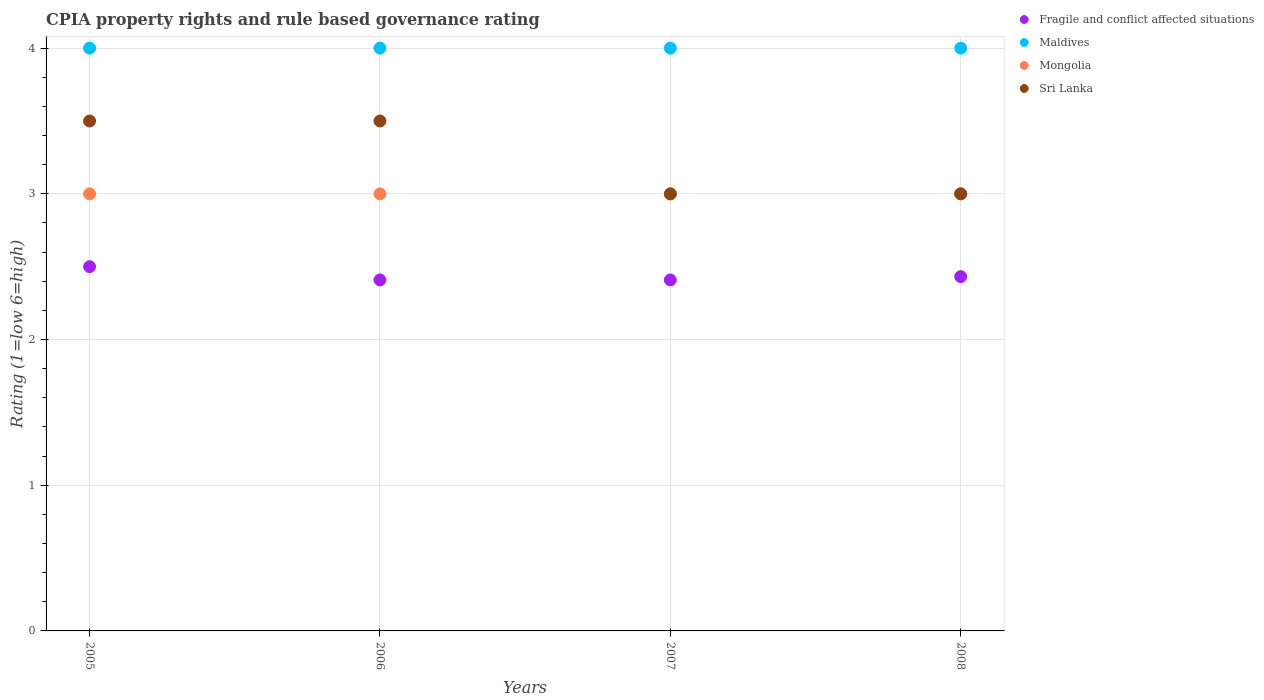How many different coloured dotlines are there?
Your answer should be very brief. 4. What is the CPIA rating in Mongolia in 2007?
Provide a short and direct response. 3. Across all years, what is the minimum CPIA rating in Mongolia?
Make the answer very short. 3. What is the total CPIA rating in Fragile and conflict affected situations in the graph?
Offer a very short reply. 9.75. What is the difference between the CPIA rating in Fragile and conflict affected situations in 2006 and the CPIA rating in Maldives in 2008?
Your response must be concise. -1.59. Is the CPIA rating in Sri Lanka in 2007 less than that in 2008?
Keep it short and to the point. No. What is the difference between the highest and the second highest CPIA rating in Mongolia?
Make the answer very short. 0. In how many years, is the CPIA rating in Mongolia greater than the average CPIA rating in Mongolia taken over all years?
Give a very brief answer. 0. Does the CPIA rating in Maldives monotonically increase over the years?
Your response must be concise. No. Is the CPIA rating in Fragile and conflict affected situations strictly greater than the CPIA rating in Mongolia over the years?
Offer a very short reply. No. Is the CPIA rating in Maldives strictly less than the CPIA rating in Mongolia over the years?
Your answer should be very brief. No. Are the values on the major ticks of Y-axis written in scientific E-notation?
Give a very brief answer. No. Does the graph contain any zero values?
Provide a short and direct response. No. Does the graph contain grids?
Your answer should be compact. Yes. What is the title of the graph?
Your answer should be very brief. CPIA property rights and rule based governance rating. Does "Tuvalu" appear as one of the legend labels in the graph?
Your answer should be compact. No. What is the label or title of the X-axis?
Your response must be concise. Years. What is the label or title of the Y-axis?
Ensure brevity in your answer.  Rating (1=low 6=high). What is the Rating (1=low 6=high) of Mongolia in 2005?
Ensure brevity in your answer.  3. What is the Rating (1=low 6=high) of Sri Lanka in 2005?
Provide a short and direct response. 3.5. What is the Rating (1=low 6=high) in Fragile and conflict affected situations in 2006?
Give a very brief answer. 2.41. What is the Rating (1=low 6=high) in Maldives in 2006?
Make the answer very short. 4. What is the Rating (1=low 6=high) of Mongolia in 2006?
Your response must be concise. 3. What is the Rating (1=low 6=high) in Fragile and conflict affected situations in 2007?
Your answer should be compact. 2.41. What is the Rating (1=low 6=high) of Fragile and conflict affected situations in 2008?
Provide a short and direct response. 2.43. What is the Rating (1=low 6=high) of Mongolia in 2008?
Make the answer very short. 3. Across all years, what is the maximum Rating (1=low 6=high) in Fragile and conflict affected situations?
Offer a terse response. 2.5. Across all years, what is the maximum Rating (1=low 6=high) of Maldives?
Offer a terse response. 4. Across all years, what is the minimum Rating (1=low 6=high) in Fragile and conflict affected situations?
Your answer should be very brief. 2.41. Across all years, what is the minimum Rating (1=low 6=high) in Maldives?
Offer a very short reply. 4. Across all years, what is the minimum Rating (1=low 6=high) in Mongolia?
Give a very brief answer. 3. Across all years, what is the minimum Rating (1=low 6=high) in Sri Lanka?
Make the answer very short. 3. What is the total Rating (1=low 6=high) of Fragile and conflict affected situations in the graph?
Make the answer very short. 9.75. What is the total Rating (1=low 6=high) in Mongolia in the graph?
Ensure brevity in your answer.  12. What is the total Rating (1=low 6=high) of Sri Lanka in the graph?
Give a very brief answer. 13. What is the difference between the Rating (1=low 6=high) in Fragile and conflict affected situations in 2005 and that in 2006?
Offer a terse response. 0.09. What is the difference between the Rating (1=low 6=high) in Maldives in 2005 and that in 2006?
Provide a short and direct response. 0. What is the difference between the Rating (1=low 6=high) in Mongolia in 2005 and that in 2006?
Your response must be concise. 0. What is the difference between the Rating (1=low 6=high) in Fragile and conflict affected situations in 2005 and that in 2007?
Make the answer very short. 0.09. What is the difference between the Rating (1=low 6=high) of Mongolia in 2005 and that in 2007?
Ensure brevity in your answer.  0. What is the difference between the Rating (1=low 6=high) of Fragile and conflict affected situations in 2005 and that in 2008?
Provide a succinct answer. 0.07. What is the difference between the Rating (1=low 6=high) in Mongolia in 2005 and that in 2008?
Provide a succinct answer. 0. What is the difference between the Rating (1=low 6=high) of Sri Lanka in 2005 and that in 2008?
Give a very brief answer. 0.5. What is the difference between the Rating (1=low 6=high) in Mongolia in 2006 and that in 2007?
Give a very brief answer. 0. What is the difference between the Rating (1=low 6=high) in Sri Lanka in 2006 and that in 2007?
Offer a terse response. 0.5. What is the difference between the Rating (1=low 6=high) in Fragile and conflict affected situations in 2006 and that in 2008?
Make the answer very short. -0.02. What is the difference between the Rating (1=low 6=high) of Maldives in 2006 and that in 2008?
Make the answer very short. 0. What is the difference between the Rating (1=low 6=high) in Sri Lanka in 2006 and that in 2008?
Your answer should be very brief. 0.5. What is the difference between the Rating (1=low 6=high) of Fragile and conflict affected situations in 2007 and that in 2008?
Make the answer very short. -0.02. What is the difference between the Rating (1=low 6=high) in Maldives in 2007 and that in 2008?
Provide a short and direct response. 0. What is the difference between the Rating (1=low 6=high) of Mongolia in 2007 and that in 2008?
Ensure brevity in your answer.  0. What is the difference between the Rating (1=low 6=high) of Sri Lanka in 2007 and that in 2008?
Your answer should be very brief. 0. What is the difference between the Rating (1=low 6=high) in Fragile and conflict affected situations in 2005 and the Rating (1=low 6=high) in Maldives in 2006?
Offer a terse response. -1.5. What is the difference between the Rating (1=low 6=high) of Maldives in 2005 and the Rating (1=low 6=high) of Mongolia in 2006?
Offer a terse response. 1. What is the difference between the Rating (1=low 6=high) in Fragile and conflict affected situations in 2005 and the Rating (1=low 6=high) in Mongolia in 2007?
Your response must be concise. -0.5. What is the difference between the Rating (1=low 6=high) in Maldives in 2005 and the Rating (1=low 6=high) in Mongolia in 2007?
Your response must be concise. 1. What is the difference between the Rating (1=low 6=high) of Maldives in 2005 and the Rating (1=low 6=high) of Sri Lanka in 2007?
Your answer should be compact. 1. What is the difference between the Rating (1=low 6=high) of Fragile and conflict affected situations in 2005 and the Rating (1=low 6=high) of Sri Lanka in 2008?
Your answer should be compact. -0.5. What is the difference between the Rating (1=low 6=high) in Maldives in 2005 and the Rating (1=low 6=high) in Sri Lanka in 2008?
Provide a short and direct response. 1. What is the difference between the Rating (1=low 6=high) of Mongolia in 2005 and the Rating (1=low 6=high) of Sri Lanka in 2008?
Your answer should be very brief. 0. What is the difference between the Rating (1=low 6=high) of Fragile and conflict affected situations in 2006 and the Rating (1=low 6=high) of Maldives in 2007?
Ensure brevity in your answer.  -1.59. What is the difference between the Rating (1=low 6=high) of Fragile and conflict affected situations in 2006 and the Rating (1=low 6=high) of Mongolia in 2007?
Provide a succinct answer. -0.59. What is the difference between the Rating (1=low 6=high) of Fragile and conflict affected situations in 2006 and the Rating (1=low 6=high) of Sri Lanka in 2007?
Provide a short and direct response. -0.59. What is the difference between the Rating (1=low 6=high) in Maldives in 2006 and the Rating (1=low 6=high) in Mongolia in 2007?
Your answer should be compact. 1. What is the difference between the Rating (1=low 6=high) of Mongolia in 2006 and the Rating (1=low 6=high) of Sri Lanka in 2007?
Make the answer very short. 0. What is the difference between the Rating (1=low 6=high) in Fragile and conflict affected situations in 2006 and the Rating (1=low 6=high) in Maldives in 2008?
Provide a succinct answer. -1.59. What is the difference between the Rating (1=low 6=high) of Fragile and conflict affected situations in 2006 and the Rating (1=low 6=high) of Mongolia in 2008?
Ensure brevity in your answer.  -0.59. What is the difference between the Rating (1=low 6=high) in Fragile and conflict affected situations in 2006 and the Rating (1=low 6=high) in Sri Lanka in 2008?
Give a very brief answer. -0.59. What is the difference between the Rating (1=low 6=high) of Mongolia in 2006 and the Rating (1=low 6=high) of Sri Lanka in 2008?
Provide a short and direct response. 0. What is the difference between the Rating (1=low 6=high) in Fragile and conflict affected situations in 2007 and the Rating (1=low 6=high) in Maldives in 2008?
Offer a terse response. -1.59. What is the difference between the Rating (1=low 6=high) in Fragile and conflict affected situations in 2007 and the Rating (1=low 6=high) in Mongolia in 2008?
Your response must be concise. -0.59. What is the difference between the Rating (1=low 6=high) of Fragile and conflict affected situations in 2007 and the Rating (1=low 6=high) of Sri Lanka in 2008?
Your response must be concise. -0.59. What is the difference between the Rating (1=low 6=high) of Maldives in 2007 and the Rating (1=low 6=high) of Mongolia in 2008?
Make the answer very short. 1. What is the difference between the Rating (1=low 6=high) of Maldives in 2007 and the Rating (1=low 6=high) of Sri Lanka in 2008?
Offer a very short reply. 1. What is the difference between the Rating (1=low 6=high) in Mongolia in 2007 and the Rating (1=low 6=high) in Sri Lanka in 2008?
Your response must be concise. 0. What is the average Rating (1=low 6=high) in Fragile and conflict affected situations per year?
Make the answer very short. 2.44. What is the average Rating (1=low 6=high) in Maldives per year?
Your answer should be very brief. 4. In the year 2006, what is the difference between the Rating (1=low 6=high) in Fragile and conflict affected situations and Rating (1=low 6=high) in Maldives?
Give a very brief answer. -1.59. In the year 2006, what is the difference between the Rating (1=low 6=high) of Fragile and conflict affected situations and Rating (1=low 6=high) of Mongolia?
Keep it short and to the point. -0.59. In the year 2006, what is the difference between the Rating (1=low 6=high) of Fragile and conflict affected situations and Rating (1=low 6=high) of Sri Lanka?
Give a very brief answer. -1.09. In the year 2006, what is the difference between the Rating (1=low 6=high) in Maldives and Rating (1=low 6=high) in Sri Lanka?
Keep it short and to the point. 0.5. In the year 2007, what is the difference between the Rating (1=low 6=high) in Fragile and conflict affected situations and Rating (1=low 6=high) in Maldives?
Keep it short and to the point. -1.59. In the year 2007, what is the difference between the Rating (1=low 6=high) in Fragile and conflict affected situations and Rating (1=low 6=high) in Mongolia?
Make the answer very short. -0.59. In the year 2007, what is the difference between the Rating (1=low 6=high) in Fragile and conflict affected situations and Rating (1=low 6=high) in Sri Lanka?
Your response must be concise. -0.59. In the year 2007, what is the difference between the Rating (1=low 6=high) in Maldives and Rating (1=low 6=high) in Mongolia?
Your response must be concise. 1. In the year 2008, what is the difference between the Rating (1=low 6=high) of Fragile and conflict affected situations and Rating (1=low 6=high) of Maldives?
Provide a short and direct response. -1.57. In the year 2008, what is the difference between the Rating (1=low 6=high) of Fragile and conflict affected situations and Rating (1=low 6=high) of Mongolia?
Make the answer very short. -0.57. In the year 2008, what is the difference between the Rating (1=low 6=high) in Fragile and conflict affected situations and Rating (1=low 6=high) in Sri Lanka?
Your answer should be compact. -0.57. In the year 2008, what is the difference between the Rating (1=low 6=high) in Maldives and Rating (1=low 6=high) in Mongolia?
Give a very brief answer. 1. In the year 2008, what is the difference between the Rating (1=low 6=high) in Maldives and Rating (1=low 6=high) in Sri Lanka?
Provide a succinct answer. 1. In the year 2008, what is the difference between the Rating (1=low 6=high) in Mongolia and Rating (1=low 6=high) in Sri Lanka?
Provide a short and direct response. 0. What is the ratio of the Rating (1=low 6=high) in Fragile and conflict affected situations in 2005 to that in 2006?
Your response must be concise. 1.04. What is the ratio of the Rating (1=low 6=high) in Maldives in 2005 to that in 2006?
Your answer should be very brief. 1. What is the ratio of the Rating (1=low 6=high) in Sri Lanka in 2005 to that in 2006?
Keep it short and to the point. 1. What is the ratio of the Rating (1=low 6=high) in Fragile and conflict affected situations in 2005 to that in 2007?
Give a very brief answer. 1.04. What is the ratio of the Rating (1=low 6=high) of Mongolia in 2005 to that in 2007?
Offer a very short reply. 1. What is the ratio of the Rating (1=low 6=high) in Fragile and conflict affected situations in 2005 to that in 2008?
Provide a short and direct response. 1.03. What is the ratio of the Rating (1=low 6=high) of Mongolia in 2005 to that in 2008?
Ensure brevity in your answer.  1. What is the ratio of the Rating (1=low 6=high) of Fragile and conflict affected situations in 2006 to that in 2007?
Your answer should be very brief. 1. What is the ratio of the Rating (1=low 6=high) in Mongolia in 2006 to that in 2007?
Ensure brevity in your answer.  1. What is the ratio of the Rating (1=low 6=high) in Fragile and conflict affected situations in 2006 to that in 2008?
Keep it short and to the point. 0.99. What is the ratio of the Rating (1=low 6=high) in Sri Lanka in 2006 to that in 2008?
Offer a very short reply. 1.17. What is the ratio of the Rating (1=low 6=high) in Fragile and conflict affected situations in 2007 to that in 2008?
Give a very brief answer. 0.99. What is the ratio of the Rating (1=low 6=high) in Mongolia in 2007 to that in 2008?
Your answer should be very brief. 1. What is the difference between the highest and the second highest Rating (1=low 6=high) of Fragile and conflict affected situations?
Offer a very short reply. 0.07. What is the difference between the highest and the second highest Rating (1=low 6=high) of Maldives?
Your response must be concise. 0. What is the difference between the highest and the lowest Rating (1=low 6=high) in Fragile and conflict affected situations?
Ensure brevity in your answer.  0.09. What is the difference between the highest and the lowest Rating (1=low 6=high) in Maldives?
Your answer should be compact. 0. What is the difference between the highest and the lowest Rating (1=low 6=high) in Mongolia?
Your answer should be compact. 0. 